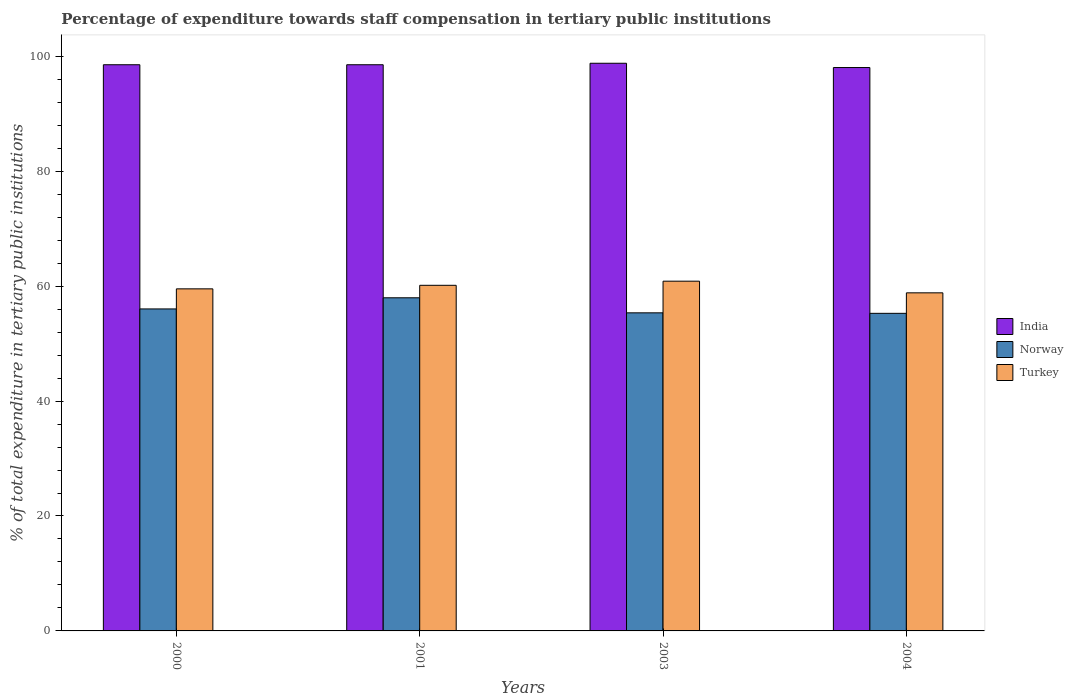How many different coloured bars are there?
Make the answer very short. 3. Are the number of bars per tick equal to the number of legend labels?
Your response must be concise. Yes. Are the number of bars on each tick of the X-axis equal?
Offer a very short reply. Yes. How many bars are there on the 2nd tick from the right?
Offer a very short reply. 3. What is the label of the 4th group of bars from the left?
Provide a short and direct response. 2004. What is the percentage of expenditure towards staff compensation in Norway in 2001?
Make the answer very short. 57.97. Across all years, what is the maximum percentage of expenditure towards staff compensation in Norway?
Give a very brief answer. 57.97. Across all years, what is the minimum percentage of expenditure towards staff compensation in Turkey?
Offer a very short reply. 58.84. In which year was the percentage of expenditure towards staff compensation in Norway maximum?
Provide a succinct answer. 2001. What is the total percentage of expenditure towards staff compensation in Norway in the graph?
Offer a very short reply. 224.63. What is the difference between the percentage of expenditure towards staff compensation in Turkey in 2000 and that in 2004?
Ensure brevity in your answer.  0.69. What is the difference between the percentage of expenditure towards staff compensation in Norway in 2000 and the percentage of expenditure towards staff compensation in Turkey in 2001?
Your answer should be compact. -4.11. What is the average percentage of expenditure towards staff compensation in Turkey per year?
Ensure brevity in your answer.  59.84. In the year 2001, what is the difference between the percentage of expenditure towards staff compensation in Turkey and percentage of expenditure towards staff compensation in Norway?
Offer a terse response. 2.17. In how many years, is the percentage of expenditure towards staff compensation in Turkey greater than 4 %?
Offer a terse response. 4. What is the ratio of the percentage of expenditure towards staff compensation in Norway in 2001 to that in 2004?
Give a very brief answer. 1.05. Is the difference between the percentage of expenditure towards staff compensation in Turkey in 2000 and 2004 greater than the difference between the percentage of expenditure towards staff compensation in Norway in 2000 and 2004?
Provide a succinct answer. No. What is the difference between the highest and the second highest percentage of expenditure towards staff compensation in Turkey?
Keep it short and to the point. 0.72. What is the difference between the highest and the lowest percentage of expenditure towards staff compensation in Turkey?
Offer a terse response. 2.03. What does the 1st bar from the right in 2001 represents?
Keep it short and to the point. Turkey. Is it the case that in every year, the sum of the percentage of expenditure towards staff compensation in India and percentage of expenditure towards staff compensation in Norway is greater than the percentage of expenditure towards staff compensation in Turkey?
Offer a very short reply. Yes. How many bars are there?
Your answer should be compact. 12. Are all the bars in the graph horizontal?
Provide a succinct answer. No. Does the graph contain grids?
Ensure brevity in your answer.  No. How many legend labels are there?
Offer a terse response. 3. How are the legend labels stacked?
Provide a short and direct response. Vertical. What is the title of the graph?
Make the answer very short. Percentage of expenditure towards staff compensation in tertiary public institutions. What is the label or title of the X-axis?
Offer a very short reply. Years. What is the label or title of the Y-axis?
Offer a terse response. % of total expenditure in tertiary public institutions. What is the % of total expenditure in tertiary public institutions of India in 2000?
Offer a terse response. 98.53. What is the % of total expenditure in tertiary public institutions in Norway in 2000?
Give a very brief answer. 56.04. What is the % of total expenditure in tertiary public institutions of Turkey in 2000?
Provide a short and direct response. 59.53. What is the % of total expenditure in tertiary public institutions of India in 2001?
Offer a terse response. 98.53. What is the % of total expenditure in tertiary public institutions of Norway in 2001?
Provide a succinct answer. 57.97. What is the % of total expenditure in tertiary public institutions in Turkey in 2001?
Your response must be concise. 60.15. What is the % of total expenditure in tertiary public institutions in India in 2003?
Your answer should be very brief. 98.79. What is the % of total expenditure in tertiary public institutions of Norway in 2003?
Make the answer very short. 55.36. What is the % of total expenditure in tertiary public institutions of Turkey in 2003?
Your answer should be compact. 60.86. What is the % of total expenditure in tertiary public institutions of India in 2004?
Ensure brevity in your answer.  98.04. What is the % of total expenditure in tertiary public institutions in Norway in 2004?
Your answer should be very brief. 55.27. What is the % of total expenditure in tertiary public institutions in Turkey in 2004?
Keep it short and to the point. 58.84. Across all years, what is the maximum % of total expenditure in tertiary public institutions of India?
Offer a terse response. 98.79. Across all years, what is the maximum % of total expenditure in tertiary public institutions in Norway?
Offer a terse response. 57.97. Across all years, what is the maximum % of total expenditure in tertiary public institutions of Turkey?
Keep it short and to the point. 60.86. Across all years, what is the minimum % of total expenditure in tertiary public institutions in India?
Keep it short and to the point. 98.04. Across all years, what is the minimum % of total expenditure in tertiary public institutions in Norway?
Your answer should be very brief. 55.27. Across all years, what is the minimum % of total expenditure in tertiary public institutions in Turkey?
Keep it short and to the point. 58.84. What is the total % of total expenditure in tertiary public institutions of India in the graph?
Your answer should be compact. 393.89. What is the total % of total expenditure in tertiary public institutions in Norway in the graph?
Ensure brevity in your answer.  224.63. What is the total % of total expenditure in tertiary public institutions of Turkey in the graph?
Give a very brief answer. 239.38. What is the difference between the % of total expenditure in tertiary public institutions in India in 2000 and that in 2001?
Keep it short and to the point. 0. What is the difference between the % of total expenditure in tertiary public institutions of Norway in 2000 and that in 2001?
Your answer should be compact. -1.94. What is the difference between the % of total expenditure in tertiary public institutions in Turkey in 2000 and that in 2001?
Ensure brevity in your answer.  -0.62. What is the difference between the % of total expenditure in tertiary public institutions of India in 2000 and that in 2003?
Your answer should be very brief. -0.26. What is the difference between the % of total expenditure in tertiary public institutions of Norway in 2000 and that in 2003?
Offer a very short reply. 0.68. What is the difference between the % of total expenditure in tertiary public institutions of Turkey in 2000 and that in 2003?
Keep it short and to the point. -1.33. What is the difference between the % of total expenditure in tertiary public institutions in India in 2000 and that in 2004?
Keep it short and to the point. 0.49. What is the difference between the % of total expenditure in tertiary public institutions in Norway in 2000 and that in 2004?
Provide a succinct answer. 0.77. What is the difference between the % of total expenditure in tertiary public institutions in Turkey in 2000 and that in 2004?
Your answer should be compact. 0.69. What is the difference between the % of total expenditure in tertiary public institutions of India in 2001 and that in 2003?
Offer a very short reply. -0.26. What is the difference between the % of total expenditure in tertiary public institutions in Norway in 2001 and that in 2003?
Ensure brevity in your answer.  2.62. What is the difference between the % of total expenditure in tertiary public institutions in Turkey in 2001 and that in 2003?
Provide a short and direct response. -0.72. What is the difference between the % of total expenditure in tertiary public institutions in India in 2001 and that in 2004?
Keep it short and to the point. 0.49. What is the difference between the % of total expenditure in tertiary public institutions in Norway in 2001 and that in 2004?
Provide a short and direct response. 2.71. What is the difference between the % of total expenditure in tertiary public institutions in Turkey in 2001 and that in 2004?
Your answer should be very brief. 1.31. What is the difference between the % of total expenditure in tertiary public institutions in India in 2003 and that in 2004?
Keep it short and to the point. 0.75. What is the difference between the % of total expenditure in tertiary public institutions of Norway in 2003 and that in 2004?
Your answer should be very brief. 0.09. What is the difference between the % of total expenditure in tertiary public institutions in Turkey in 2003 and that in 2004?
Keep it short and to the point. 2.03. What is the difference between the % of total expenditure in tertiary public institutions of India in 2000 and the % of total expenditure in tertiary public institutions of Norway in 2001?
Your answer should be very brief. 40.56. What is the difference between the % of total expenditure in tertiary public institutions in India in 2000 and the % of total expenditure in tertiary public institutions in Turkey in 2001?
Make the answer very short. 38.38. What is the difference between the % of total expenditure in tertiary public institutions of Norway in 2000 and the % of total expenditure in tertiary public institutions of Turkey in 2001?
Provide a short and direct response. -4.11. What is the difference between the % of total expenditure in tertiary public institutions of India in 2000 and the % of total expenditure in tertiary public institutions of Norway in 2003?
Offer a terse response. 43.17. What is the difference between the % of total expenditure in tertiary public institutions in India in 2000 and the % of total expenditure in tertiary public institutions in Turkey in 2003?
Provide a succinct answer. 37.67. What is the difference between the % of total expenditure in tertiary public institutions in Norway in 2000 and the % of total expenditure in tertiary public institutions in Turkey in 2003?
Provide a succinct answer. -4.83. What is the difference between the % of total expenditure in tertiary public institutions in India in 2000 and the % of total expenditure in tertiary public institutions in Norway in 2004?
Offer a terse response. 43.26. What is the difference between the % of total expenditure in tertiary public institutions in India in 2000 and the % of total expenditure in tertiary public institutions in Turkey in 2004?
Ensure brevity in your answer.  39.69. What is the difference between the % of total expenditure in tertiary public institutions of Norway in 2000 and the % of total expenditure in tertiary public institutions of Turkey in 2004?
Make the answer very short. -2.8. What is the difference between the % of total expenditure in tertiary public institutions of India in 2001 and the % of total expenditure in tertiary public institutions of Norway in 2003?
Your answer should be very brief. 43.17. What is the difference between the % of total expenditure in tertiary public institutions of India in 2001 and the % of total expenditure in tertiary public institutions of Turkey in 2003?
Make the answer very short. 37.67. What is the difference between the % of total expenditure in tertiary public institutions of Norway in 2001 and the % of total expenditure in tertiary public institutions of Turkey in 2003?
Give a very brief answer. -2.89. What is the difference between the % of total expenditure in tertiary public institutions in India in 2001 and the % of total expenditure in tertiary public institutions in Norway in 2004?
Provide a short and direct response. 43.26. What is the difference between the % of total expenditure in tertiary public institutions of India in 2001 and the % of total expenditure in tertiary public institutions of Turkey in 2004?
Provide a succinct answer. 39.69. What is the difference between the % of total expenditure in tertiary public institutions of Norway in 2001 and the % of total expenditure in tertiary public institutions of Turkey in 2004?
Ensure brevity in your answer.  -0.86. What is the difference between the % of total expenditure in tertiary public institutions in India in 2003 and the % of total expenditure in tertiary public institutions in Norway in 2004?
Provide a short and direct response. 43.52. What is the difference between the % of total expenditure in tertiary public institutions in India in 2003 and the % of total expenditure in tertiary public institutions in Turkey in 2004?
Offer a very short reply. 39.95. What is the difference between the % of total expenditure in tertiary public institutions in Norway in 2003 and the % of total expenditure in tertiary public institutions in Turkey in 2004?
Offer a terse response. -3.48. What is the average % of total expenditure in tertiary public institutions in India per year?
Ensure brevity in your answer.  98.47. What is the average % of total expenditure in tertiary public institutions of Norway per year?
Provide a succinct answer. 56.16. What is the average % of total expenditure in tertiary public institutions of Turkey per year?
Provide a succinct answer. 59.84. In the year 2000, what is the difference between the % of total expenditure in tertiary public institutions of India and % of total expenditure in tertiary public institutions of Norway?
Ensure brevity in your answer.  42.49. In the year 2000, what is the difference between the % of total expenditure in tertiary public institutions of India and % of total expenditure in tertiary public institutions of Turkey?
Provide a short and direct response. 39. In the year 2000, what is the difference between the % of total expenditure in tertiary public institutions in Norway and % of total expenditure in tertiary public institutions in Turkey?
Your response must be concise. -3.49. In the year 2001, what is the difference between the % of total expenditure in tertiary public institutions of India and % of total expenditure in tertiary public institutions of Norway?
Your response must be concise. 40.56. In the year 2001, what is the difference between the % of total expenditure in tertiary public institutions in India and % of total expenditure in tertiary public institutions in Turkey?
Keep it short and to the point. 38.38. In the year 2001, what is the difference between the % of total expenditure in tertiary public institutions in Norway and % of total expenditure in tertiary public institutions in Turkey?
Make the answer very short. -2.17. In the year 2003, what is the difference between the % of total expenditure in tertiary public institutions of India and % of total expenditure in tertiary public institutions of Norway?
Your answer should be compact. 43.43. In the year 2003, what is the difference between the % of total expenditure in tertiary public institutions of India and % of total expenditure in tertiary public institutions of Turkey?
Keep it short and to the point. 37.92. In the year 2003, what is the difference between the % of total expenditure in tertiary public institutions of Norway and % of total expenditure in tertiary public institutions of Turkey?
Provide a short and direct response. -5.51. In the year 2004, what is the difference between the % of total expenditure in tertiary public institutions in India and % of total expenditure in tertiary public institutions in Norway?
Make the answer very short. 42.77. In the year 2004, what is the difference between the % of total expenditure in tertiary public institutions in India and % of total expenditure in tertiary public institutions in Turkey?
Your answer should be very brief. 39.21. In the year 2004, what is the difference between the % of total expenditure in tertiary public institutions in Norway and % of total expenditure in tertiary public institutions in Turkey?
Offer a terse response. -3.57. What is the ratio of the % of total expenditure in tertiary public institutions in India in 2000 to that in 2001?
Give a very brief answer. 1. What is the ratio of the % of total expenditure in tertiary public institutions in Norway in 2000 to that in 2001?
Give a very brief answer. 0.97. What is the ratio of the % of total expenditure in tertiary public institutions of Turkey in 2000 to that in 2001?
Your answer should be very brief. 0.99. What is the ratio of the % of total expenditure in tertiary public institutions in India in 2000 to that in 2003?
Keep it short and to the point. 1. What is the ratio of the % of total expenditure in tertiary public institutions in Norway in 2000 to that in 2003?
Your answer should be very brief. 1.01. What is the ratio of the % of total expenditure in tertiary public institutions in Turkey in 2000 to that in 2003?
Your answer should be very brief. 0.98. What is the ratio of the % of total expenditure in tertiary public institutions in Norway in 2000 to that in 2004?
Your response must be concise. 1.01. What is the ratio of the % of total expenditure in tertiary public institutions in Turkey in 2000 to that in 2004?
Ensure brevity in your answer.  1.01. What is the ratio of the % of total expenditure in tertiary public institutions of India in 2001 to that in 2003?
Keep it short and to the point. 1. What is the ratio of the % of total expenditure in tertiary public institutions in Norway in 2001 to that in 2003?
Keep it short and to the point. 1.05. What is the ratio of the % of total expenditure in tertiary public institutions of Turkey in 2001 to that in 2003?
Your answer should be very brief. 0.99. What is the ratio of the % of total expenditure in tertiary public institutions of India in 2001 to that in 2004?
Keep it short and to the point. 1. What is the ratio of the % of total expenditure in tertiary public institutions of Norway in 2001 to that in 2004?
Offer a terse response. 1.05. What is the ratio of the % of total expenditure in tertiary public institutions in Turkey in 2001 to that in 2004?
Your answer should be very brief. 1.02. What is the ratio of the % of total expenditure in tertiary public institutions in India in 2003 to that in 2004?
Your answer should be very brief. 1.01. What is the ratio of the % of total expenditure in tertiary public institutions in Norway in 2003 to that in 2004?
Provide a short and direct response. 1. What is the ratio of the % of total expenditure in tertiary public institutions of Turkey in 2003 to that in 2004?
Offer a terse response. 1.03. What is the difference between the highest and the second highest % of total expenditure in tertiary public institutions in India?
Keep it short and to the point. 0.26. What is the difference between the highest and the second highest % of total expenditure in tertiary public institutions of Norway?
Provide a short and direct response. 1.94. What is the difference between the highest and the second highest % of total expenditure in tertiary public institutions of Turkey?
Make the answer very short. 0.72. What is the difference between the highest and the lowest % of total expenditure in tertiary public institutions of India?
Your answer should be compact. 0.75. What is the difference between the highest and the lowest % of total expenditure in tertiary public institutions of Norway?
Provide a succinct answer. 2.71. What is the difference between the highest and the lowest % of total expenditure in tertiary public institutions in Turkey?
Make the answer very short. 2.03. 